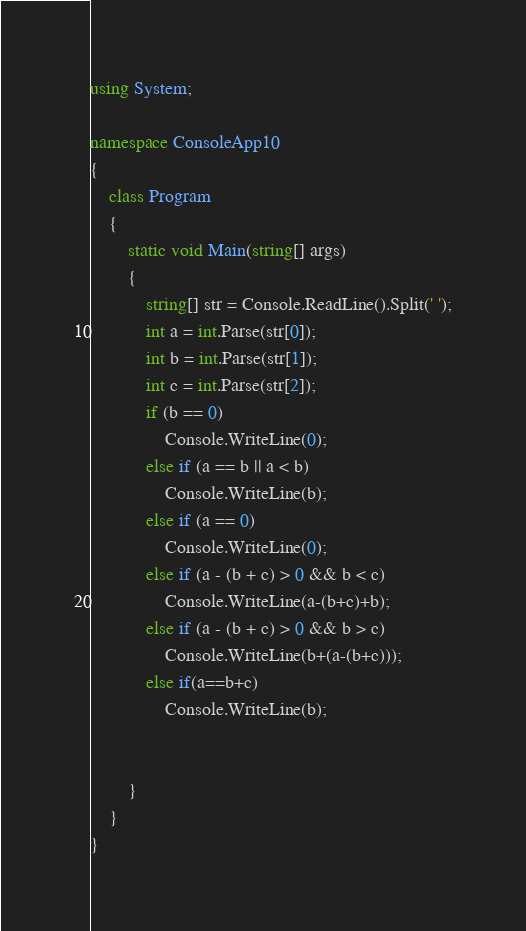<code> <loc_0><loc_0><loc_500><loc_500><_C#_>using System;

namespace ConsoleApp10
{
    class Program
    {
        static void Main(string[] args)
        {
            string[] str = Console.ReadLine().Split(' ');
            int a = int.Parse(str[0]);
            int b = int.Parse(str[1]);
            int c = int.Parse(str[2]);
            if (b == 0)
                Console.WriteLine(0);
            else if (a == b || a < b)
                Console.WriteLine(b);
            else if (a == 0)
                Console.WriteLine(0);
            else if (a - (b + c) > 0 && b < c)
                Console.WriteLine(a-(b+c)+b);
            else if (a - (b + c) > 0 && b > c)
                Console.WriteLine(b+(a-(b+c)));
            else if(a==b+c)
                Console.WriteLine(b);


        }
    }
}
</code> 